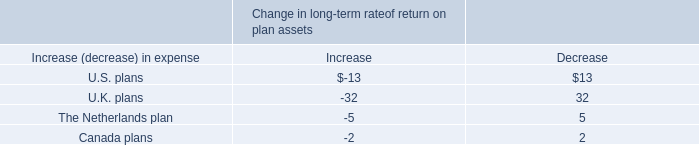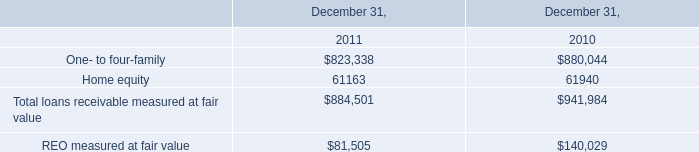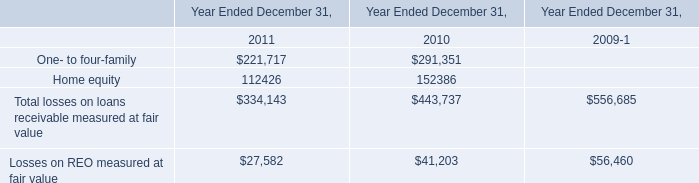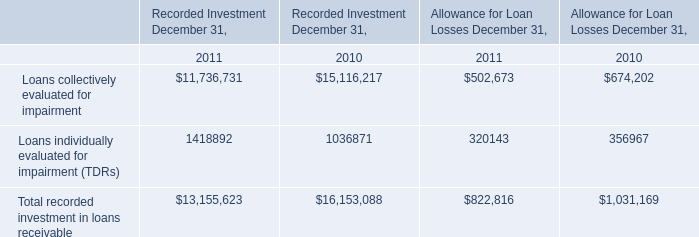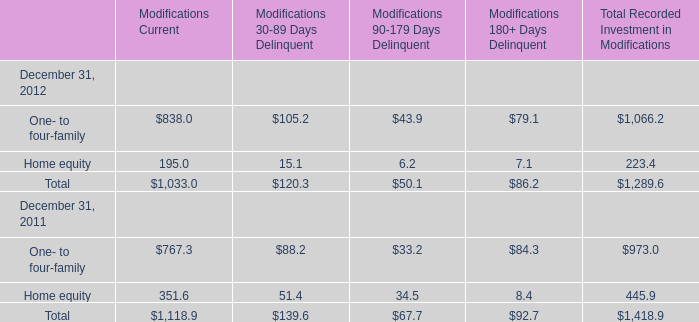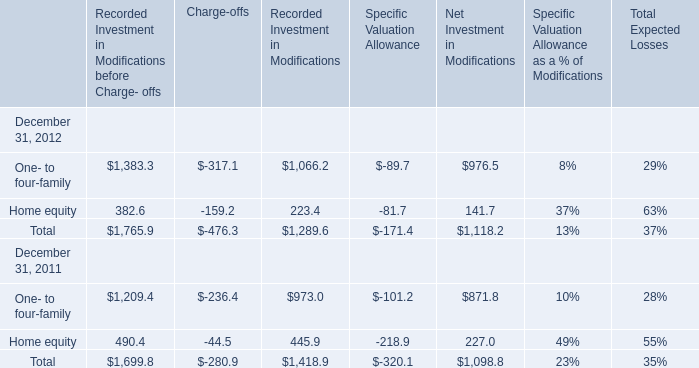What is the ratio of Home equity's Modifications Current to the total in 2012? 
Computations: (195 / 1033)
Answer: 0.18877. 